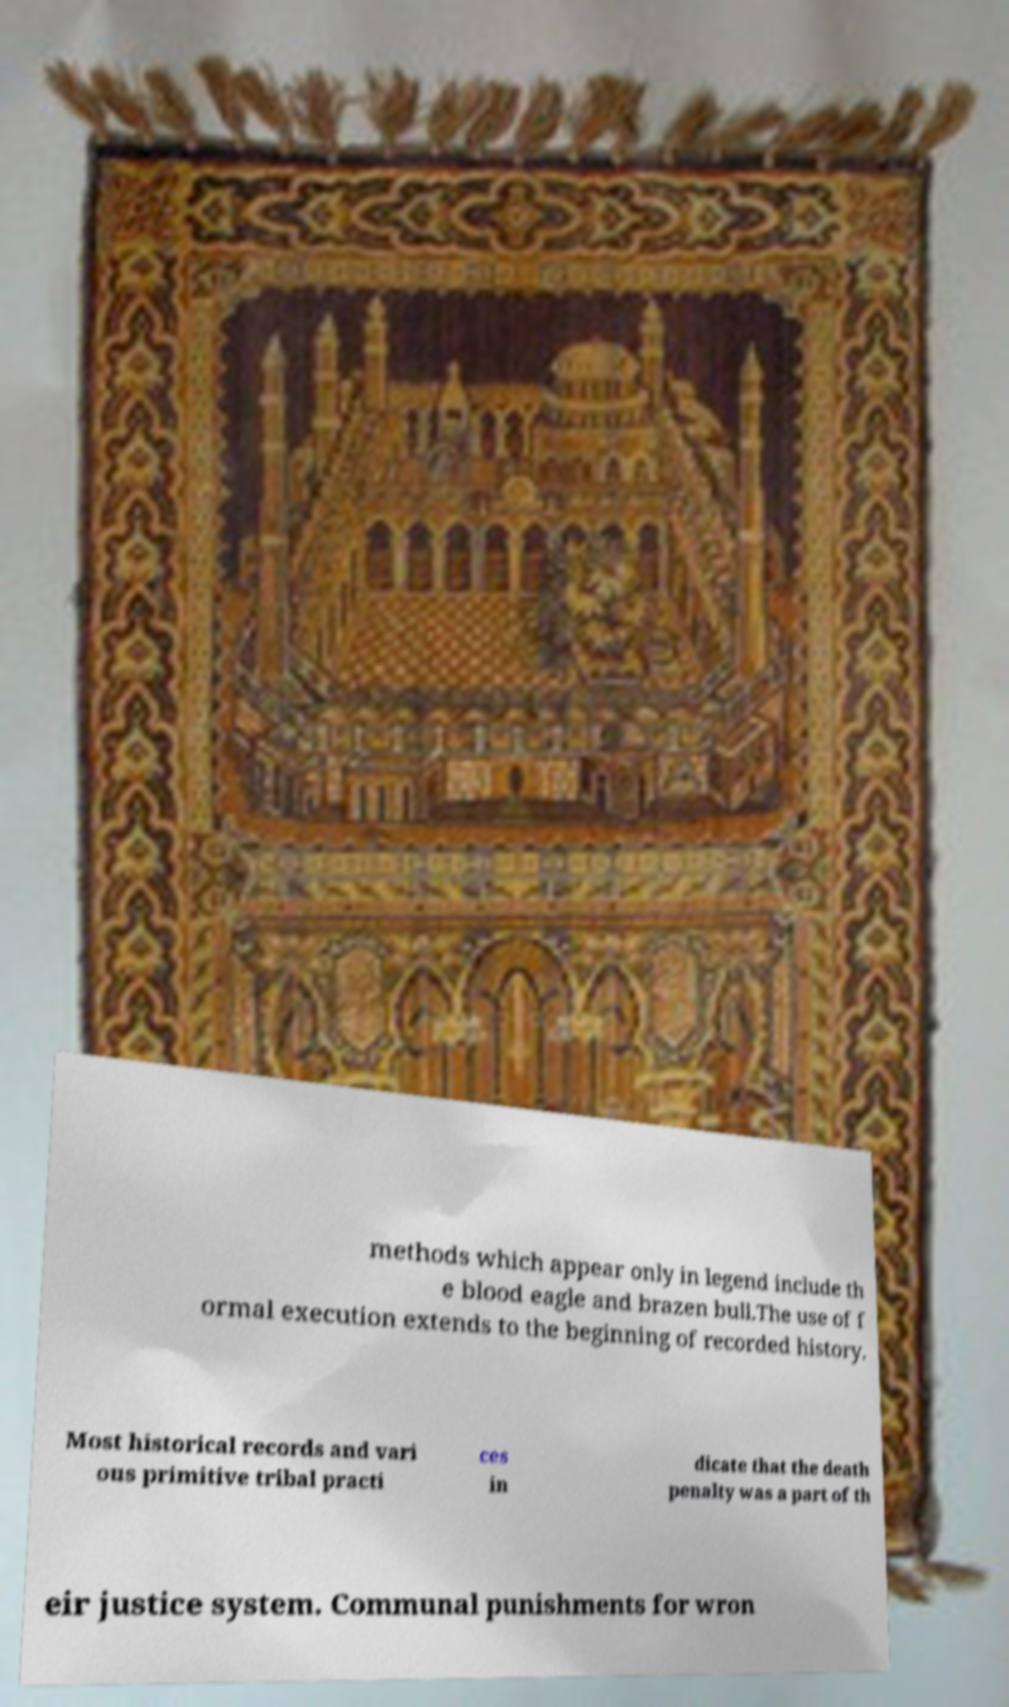Please identify and transcribe the text found in this image. methods which appear only in legend include th e blood eagle and brazen bull.The use of f ormal execution extends to the beginning of recorded history. Most historical records and vari ous primitive tribal practi ces in dicate that the death penalty was a part of th eir justice system. Communal punishments for wron 